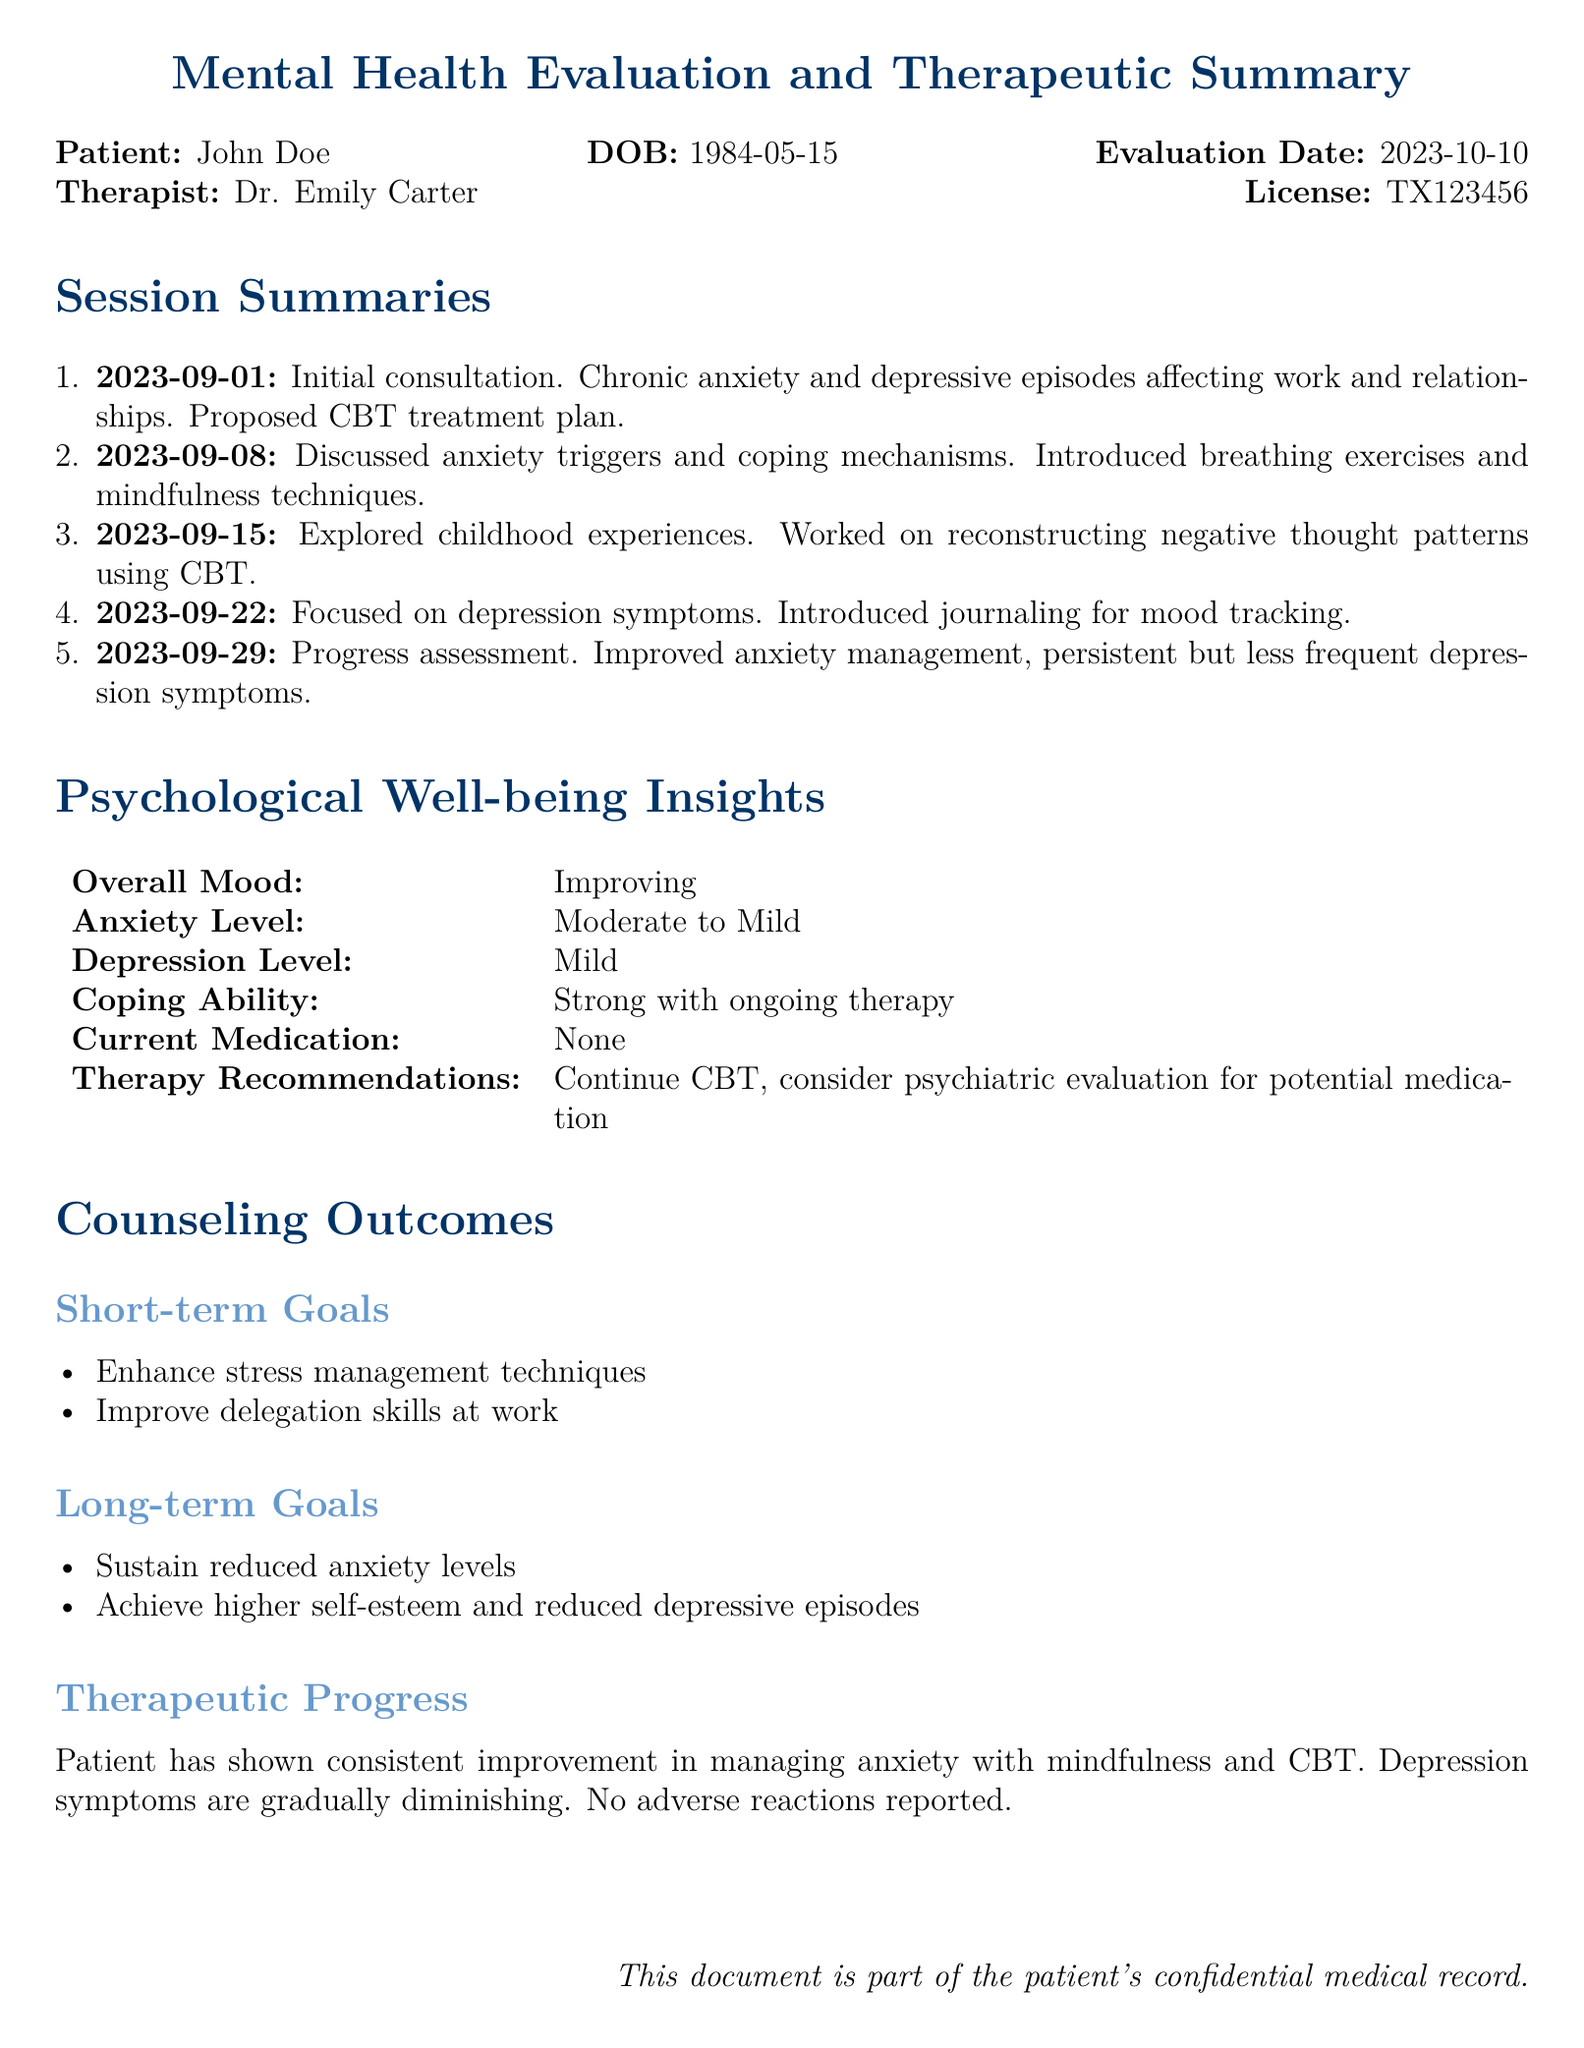What is the name of the patient? The patient's name is mentioned at the beginning of the document.
Answer: John Doe What is the date of birth of the patient? The date of birth is provided alongside the patient's name in the document.
Answer: 1984-05-15 Who is the therapist? The therapist's name is noted in the document.
Answer: Dr. Emily Carter What was the initial consultation date? The date of the initial consultation is listed in the session summaries.
Answer: 2023-09-01 What therapy is being used for treatment? The therapy type is stated in the treatment plan section of the document.
Answer: CBT What is the patient's current medication? The medication status is provided in the psychological well-being insights.
Answer: None What is a short-term goal from the counseling outcomes? Short-term goals are listed under the counseling outcomes section.
Answer: Enhance stress management techniques How has the patient's anxiety level changed? The anxiety level is described in the psychological well-being insights; it indicates a change over time.
Answer: Moderate to Mild What are the long-term goals? Long-term goals are outlined in the counseling outcomes section.
Answer: Sustain reduced anxiety levels, achieve higher self-esteem and reduced depressive episodes 